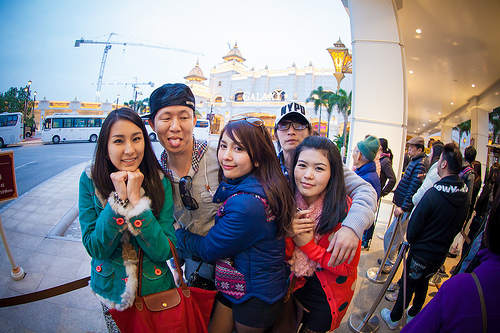<image>
Can you confirm if the men is on the women? No. The men is not positioned on the women. They may be near each other, but the men is not supported by or resting on top of the women. Is the blue girl to the left of the green girl? No. The blue girl is not to the left of the green girl. From this viewpoint, they have a different horizontal relationship. 